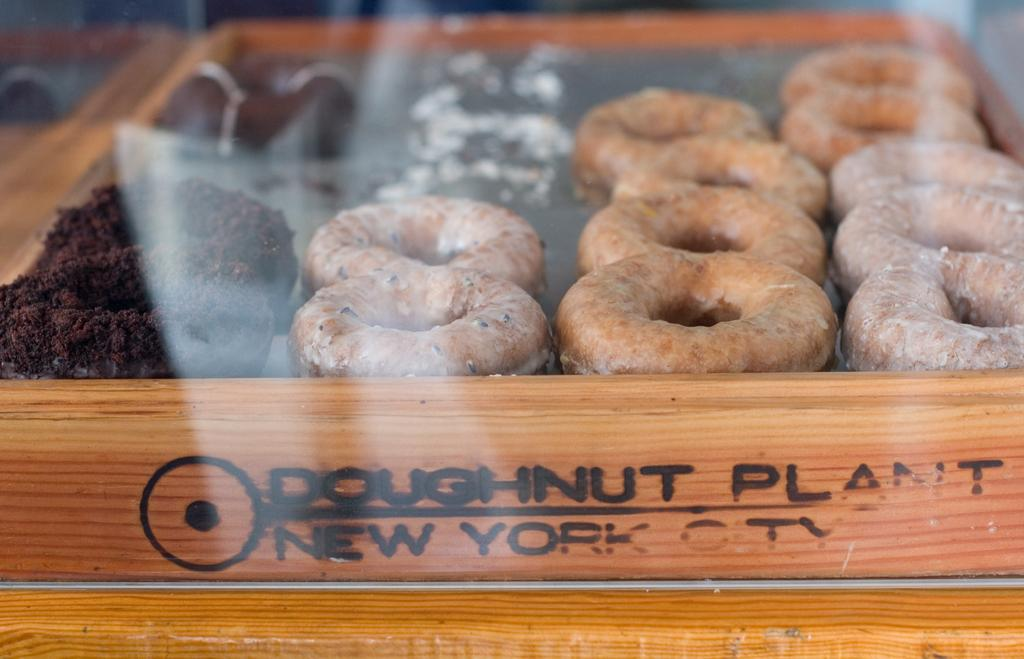What is located in the foreground of the image? There is a box in the foreground of the image. What is inside the box? The box contains doughnuts. Are there any other items in the box besides doughnuts? Yes, there are other items in the box. Can you describe any text visible in the image? There is text at the bottom side of the image. What type of gold jewelry can be seen on the stove in the image? There is no gold jewelry or stove present in the image. How many clocks are visible in the image? There are no clocks visible in the image. 